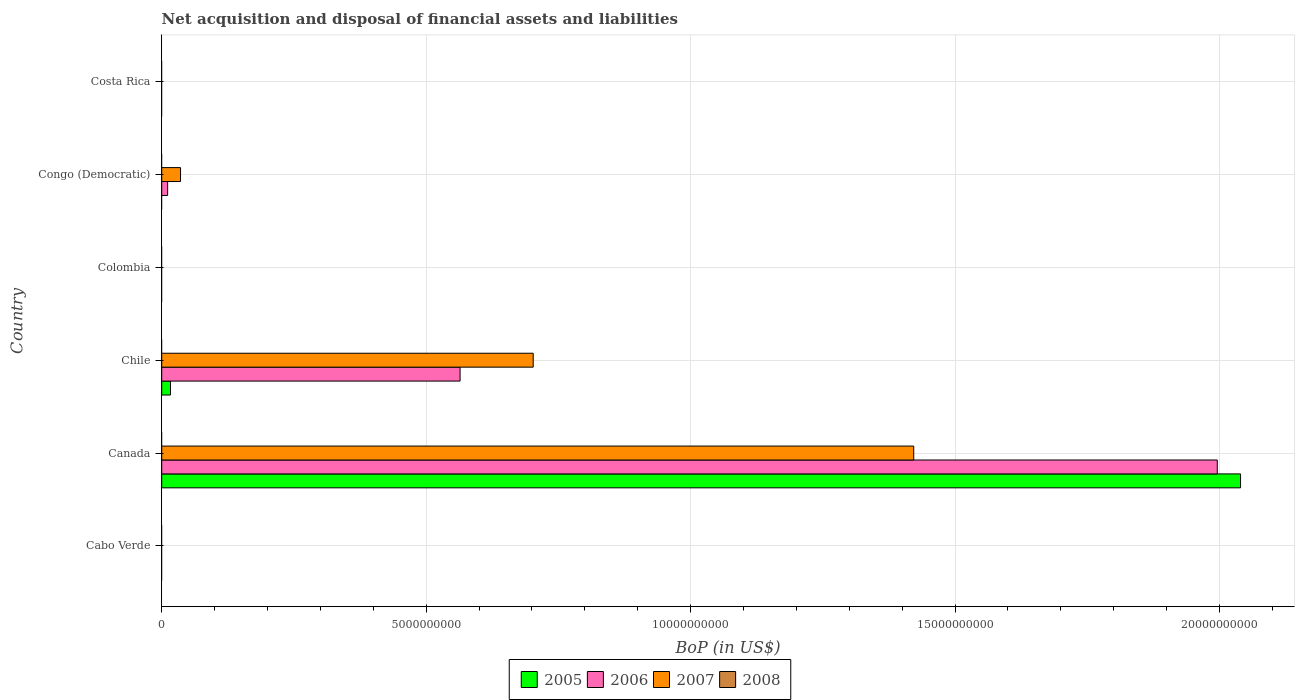Are the number of bars per tick equal to the number of legend labels?
Ensure brevity in your answer.  No. Are the number of bars on each tick of the Y-axis equal?
Your response must be concise. No. How many bars are there on the 4th tick from the top?
Provide a short and direct response. 3. What is the label of the 1st group of bars from the top?
Provide a succinct answer. Costa Rica. In how many cases, is the number of bars for a given country not equal to the number of legend labels?
Make the answer very short. 6. Across all countries, what is the maximum Balance of Payments in 2005?
Provide a succinct answer. 2.04e+1. Across all countries, what is the minimum Balance of Payments in 2007?
Give a very brief answer. 0. In which country was the Balance of Payments in 2005 maximum?
Your response must be concise. Canada. What is the total Balance of Payments in 2007 in the graph?
Keep it short and to the point. 2.16e+1. What is the difference between the Balance of Payments in 2006 in Chile and that in Congo (Democratic)?
Ensure brevity in your answer.  5.53e+09. What is the average Balance of Payments in 2007 per country?
Provide a succinct answer. 3.60e+09. What is the difference between the Balance of Payments in 2005 and Balance of Payments in 2006 in Canada?
Offer a very short reply. 4.40e+08. What is the ratio of the Balance of Payments in 2006 in Chile to that in Congo (Democratic)?
Offer a very short reply. 50.33. What is the difference between the highest and the second highest Balance of Payments in 2007?
Your response must be concise. 7.19e+09. What is the difference between the highest and the lowest Balance of Payments in 2007?
Offer a very short reply. 1.42e+1. In how many countries, is the Balance of Payments in 2008 greater than the average Balance of Payments in 2008 taken over all countries?
Your response must be concise. 0. Is the sum of the Balance of Payments in 2006 in Chile and Congo (Democratic) greater than the maximum Balance of Payments in 2008 across all countries?
Keep it short and to the point. Yes. Is it the case that in every country, the sum of the Balance of Payments in 2008 and Balance of Payments in 2006 is greater than the Balance of Payments in 2005?
Offer a very short reply. No. How many bars are there?
Offer a very short reply. 8. Are the values on the major ticks of X-axis written in scientific E-notation?
Offer a terse response. No. Does the graph contain any zero values?
Your answer should be compact. Yes. Does the graph contain grids?
Give a very brief answer. Yes. How are the legend labels stacked?
Ensure brevity in your answer.  Horizontal. What is the title of the graph?
Provide a succinct answer. Net acquisition and disposal of financial assets and liabilities. What is the label or title of the X-axis?
Your response must be concise. BoP (in US$). What is the label or title of the Y-axis?
Your response must be concise. Country. What is the BoP (in US$) in 2008 in Cabo Verde?
Ensure brevity in your answer.  0. What is the BoP (in US$) in 2005 in Canada?
Ensure brevity in your answer.  2.04e+1. What is the BoP (in US$) in 2006 in Canada?
Make the answer very short. 2.00e+1. What is the BoP (in US$) of 2007 in Canada?
Your response must be concise. 1.42e+1. What is the BoP (in US$) of 2005 in Chile?
Ensure brevity in your answer.  1.66e+08. What is the BoP (in US$) in 2006 in Chile?
Keep it short and to the point. 5.64e+09. What is the BoP (in US$) of 2007 in Chile?
Offer a terse response. 7.02e+09. What is the BoP (in US$) of 2008 in Chile?
Your answer should be compact. 0. What is the BoP (in US$) of 2008 in Colombia?
Ensure brevity in your answer.  0. What is the BoP (in US$) of 2005 in Congo (Democratic)?
Offer a terse response. 0. What is the BoP (in US$) of 2006 in Congo (Democratic)?
Ensure brevity in your answer.  1.12e+08. What is the BoP (in US$) of 2007 in Congo (Democratic)?
Provide a short and direct response. 3.56e+08. What is the BoP (in US$) in 2005 in Costa Rica?
Give a very brief answer. 0. What is the BoP (in US$) of 2007 in Costa Rica?
Offer a very short reply. 0. Across all countries, what is the maximum BoP (in US$) of 2005?
Provide a succinct answer. 2.04e+1. Across all countries, what is the maximum BoP (in US$) in 2006?
Your answer should be very brief. 2.00e+1. Across all countries, what is the maximum BoP (in US$) of 2007?
Your answer should be compact. 1.42e+1. Across all countries, what is the minimum BoP (in US$) of 2006?
Provide a succinct answer. 0. What is the total BoP (in US$) of 2005 in the graph?
Keep it short and to the point. 2.06e+1. What is the total BoP (in US$) in 2006 in the graph?
Ensure brevity in your answer.  2.57e+1. What is the total BoP (in US$) of 2007 in the graph?
Your answer should be compact. 2.16e+1. What is the total BoP (in US$) in 2008 in the graph?
Give a very brief answer. 0. What is the difference between the BoP (in US$) in 2005 in Canada and that in Chile?
Your response must be concise. 2.02e+1. What is the difference between the BoP (in US$) of 2006 in Canada and that in Chile?
Make the answer very short. 1.43e+1. What is the difference between the BoP (in US$) of 2007 in Canada and that in Chile?
Provide a succinct answer. 7.19e+09. What is the difference between the BoP (in US$) of 2006 in Canada and that in Congo (Democratic)?
Your response must be concise. 1.98e+1. What is the difference between the BoP (in US$) in 2007 in Canada and that in Congo (Democratic)?
Keep it short and to the point. 1.39e+1. What is the difference between the BoP (in US$) of 2006 in Chile and that in Congo (Democratic)?
Make the answer very short. 5.53e+09. What is the difference between the BoP (in US$) of 2007 in Chile and that in Congo (Democratic)?
Keep it short and to the point. 6.67e+09. What is the difference between the BoP (in US$) of 2005 in Canada and the BoP (in US$) of 2006 in Chile?
Your answer should be compact. 1.48e+1. What is the difference between the BoP (in US$) in 2005 in Canada and the BoP (in US$) in 2007 in Chile?
Keep it short and to the point. 1.34e+1. What is the difference between the BoP (in US$) in 2006 in Canada and the BoP (in US$) in 2007 in Chile?
Offer a terse response. 1.29e+1. What is the difference between the BoP (in US$) in 2005 in Canada and the BoP (in US$) in 2006 in Congo (Democratic)?
Your answer should be very brief. 2.03e+1. What is the difference between the BoP (in US$) in 2005 in Canada and the BoP (in US$) in 2007 in Congo (Democratic)?
Make the answer very short. 2.00e+1. What is the difference between the BoP (in US$) in 2006 in Canada and the BoP (in US$) in 2007 in Congo (Democratic)?
Provide a succinct answer. 1.96e+1. What is the difference between the BoP (in US$) of 2005 in Chile and the BoP (in US$) of 2006 in Congo (Democratic)?
Provide a short and direct response. 5.40e+07. What is the difference between the BoP (in US$) in 2005 in Chile and the BoP (in US$) in 2007 in Congo (Democratic)?
Ensure brevity in your answer.  -1.90e+08. What is the difference between the BoP (in US$) in 2006 in Chile and the BoP (in US$) in 2007 in Congo (Democratic)?
Give a very brief answer. 5.29e+09. What is the average BoP (in US$) in 2005 per country?
Offer a very short reply. 3.43e+09. What is the average BoP (in US$) of 2006 per country?
Make the answer very short. 4.29e+09. What is the average BoP (in US$) of 2007 per country?
Make the answer very short. 3.60e+09. What is the average BoP (in US$) in 2008 per country?
Your response must be concise. 0. What is the difference between the BoP (in US$) in 2005 and BoP (in US$) in 2006 in Canada?
Offer a very short reply. 4.40e+08. What is the difference between the BoP (in US$) of 2005 and BoP (in US$) of 2007 in Canada?
Keep it short and to the point. 6.18e+09. What is the difference between the BoP (in US$) in 2006 and BoP (in US$) in 2007 in Canada?
Keep it short and to the point. 5.74e+09. What is the difference between the BoP (in US$) of 2005 and BoP (in US$) of 2006 in Chile?
Ensure brevity in your answer.  -5.48e+09. What is the difference between the BoP (in US$) in 2005 and BoP (in US$) in 2007 in Chile?
Provide a succinct answer. -6.86e+09. What is the difference between the BoP (in US$) in 2006 and BoP (in US$) in 2007 in Chile?
Keep it short and to the point. -1.38e+09. What is the difference between the BoP (in US$) in 2006 and BoP (in US$) in 2007 in Congo (Democratic)?
Ensure brevity in your answer.  -2.44e+08. What is the ratio of the BoP (in US$) in 2005 in Canada to that in Chile?
Your response must be concise. 122.81. What is the ratio of the BoP (in US$) of 2006 in Canada to that in Chile?
Offer a very short reply. 3.54. What is the ratio of the BoP (in US$) in 2007 in Canada to that in Chile?
Provide a succinct answer. 2.02. What is the ratio of the BoP (in US$) of 2006 in Canada to that in Congo (Democratic)?
Ensure brevity in your answer.  178.06. What is the ratio of the BoP (in US$) of 2007 in Canada to that in Congo (Democratic)?
Provide a succinct answer. 39.95. What is the ratio of the BoP (in US$) of 2006 in Chile to that in Congo (Democratic)?
Ensure brevity in your answer.  50.33. What is the ratio of the BoP (in US$) in 2007 in Chile to that in Congo (Democratic)?
Your answer should be very brief. 19.74. What is the difference between the highest and the second highest BoP (in US$) in 2006?
Your answer should be very brief. 1.43e+1. What is the difference between the highest and the second highest BoP (in US$) of 2007?
Your answer should be compact. 7.19e+09. What is the difference between the highest and the lowest BoP (in US$) in 2005?
Provide a succinct answer. 2.04e+1. What is the difference between the highest and the lowest BoP (in US$) in 2006?
Provide a succinct answer. 2.00e+1. What is the difference between the highest and the lowest BoP (in US$) of 2007?
Offer a very short reply. 1.42e+1. 